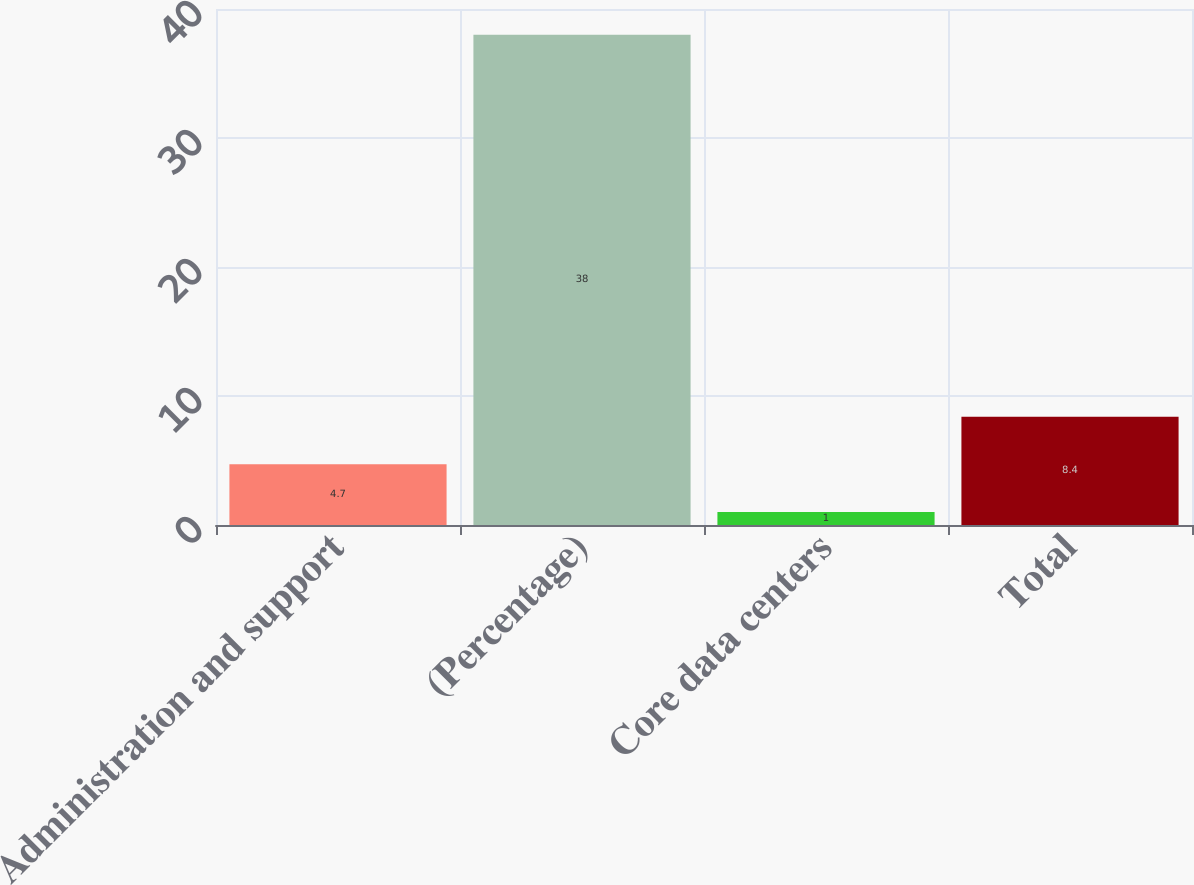<chart> <loc_0><loc_0><loc_500><loc_500><bar_chart><fcel>Administration and support<fcel>(Percentage)<fcel>Core data centers<fcel>Total<nl><fcel>4.7<fcel>38<fcel>1<fcel>8.4<nl></chart> 